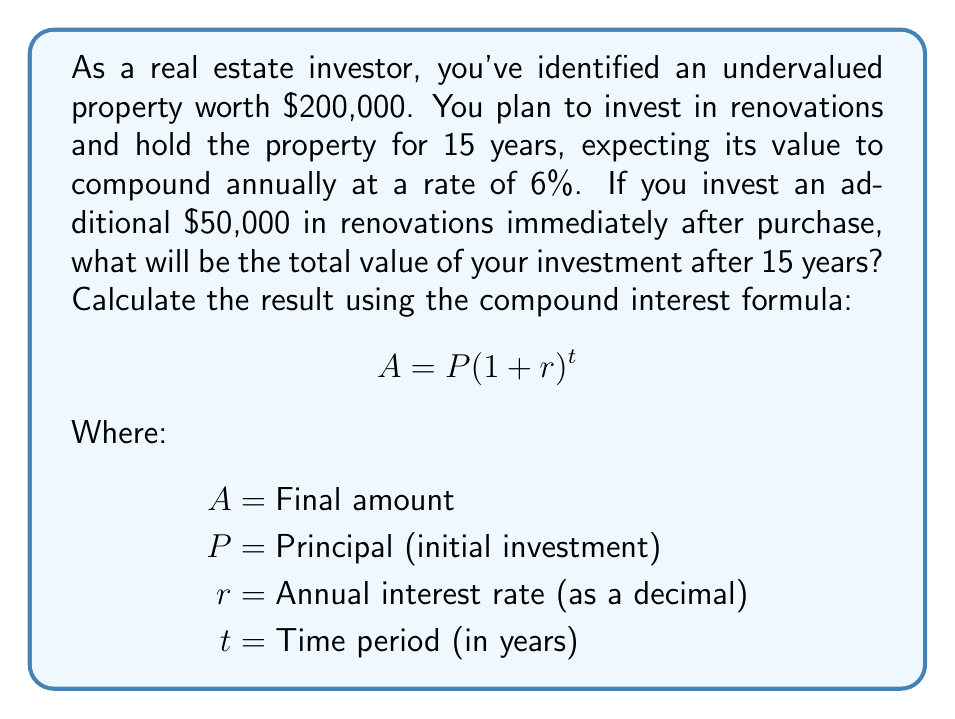Give your solution to this math problem. Let's break this problem down step-by-step:

1. Determine the initial investment (principal):
   $P = \$200,000 \text{ (property) } + \$50,000 \text{ (renovations) } = \$250,000$

2. Identify the other variables:
   $r = 6\% = 0.06$
   $t = 15 \text{ years}$

3. Apply the compound interest formula:
   $$A = P(1 + r)^t$$
   $$A = 250,000(1 + 0.06)^{15}$$

4. Calculate the result:
   $$A = 250,000(1.06)^{15}$$
   $$A = 250,000(2.3965616)$$
   $$A = 599,140.40$$

Therefore, after 15 years, the total value of your investment will be $599,140.40.
Answer: $599,140.40 